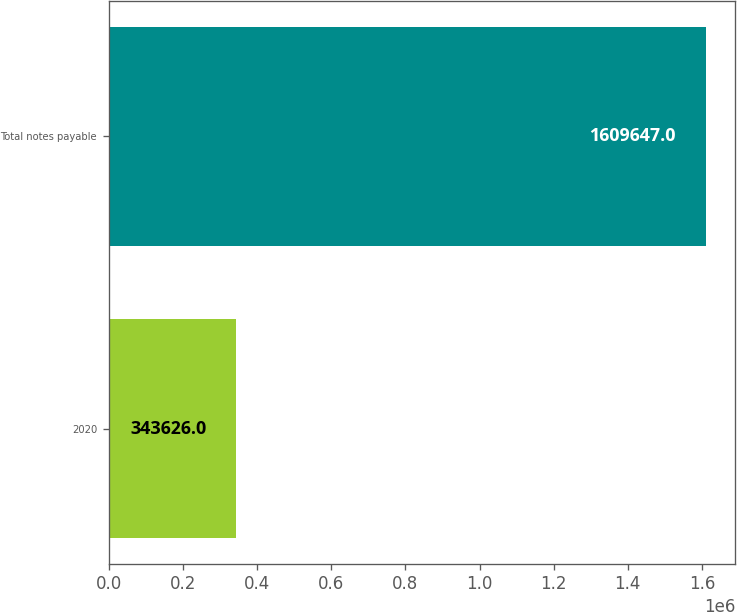<chart> <loc_0><loc_0><loc_500><loc_500><bar_chart><fcel>2020<fcel>Total notes payable<nl><fcel>343626<fcel>1.60965e+06<nl></chart> 